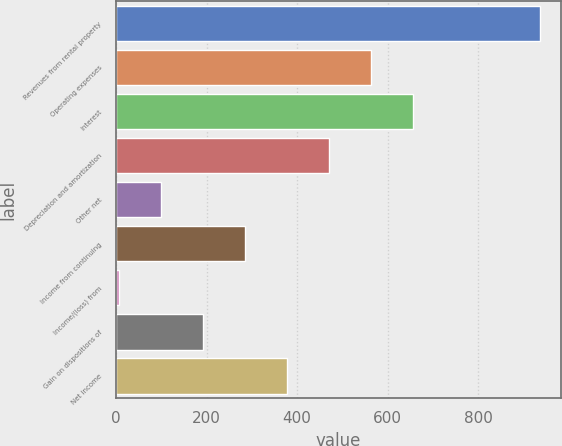Convert chart to OTSL. <chart><loc_0><loc_0><loc_500><loc_500><bar_chart><fcel>Revenues from rental property<fcel>Operating expenses<fcel>Interest<fcel>Depreciation and amortization<fcel>Other net<fcel>Income from continuing<fcel>Income/(loss) from<fcel>Gain on dispositions of<fcel>Net income<nl><fcel>936.3<fcel>564.02<fcel>657.09<fcel>470.95<fcel>98.67<fcel>284.81<fcel>5.6<fcel>191.74<fcel>377.88<nl></chart> 